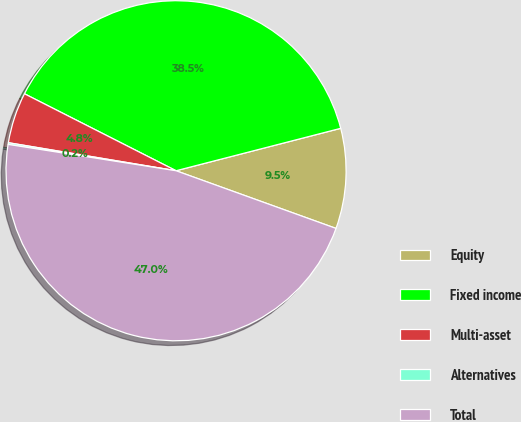Convert chart to OTSL. <chart><loc_0><loc_0><loc_500><loc_500><pie_chart><fcel>Equity<fcel>Fixed income<fcel>Multi-asset<fcel>Alternatives<fcel>Total<nl><fcel>9.52%<fcel>38.51%<fcel>4.84%<fcel>0.16%<fcel>46.97%<nl></chart> 